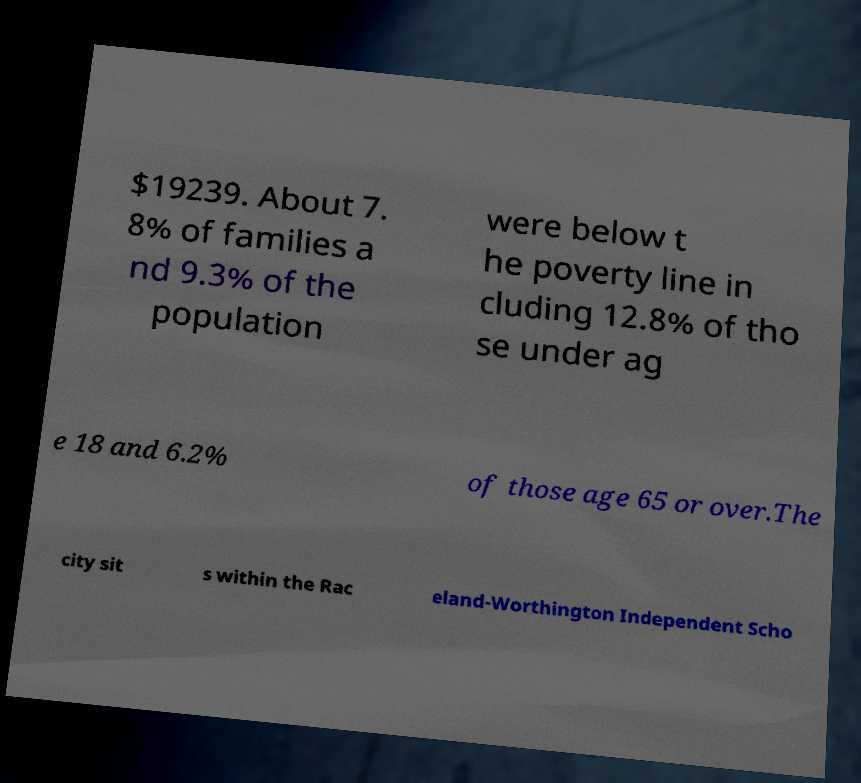There's text embedded in this image that I need extracted. Can you transcribe it verbatim? $19239. About 7. 8% of families a nd 9.3% of the population were below t he poverty line in cluding 12.8% of tho se under ag e 18 and 6.2% of those age 65 or over.The city sit s within the Rac eland-Worthington Independent Scho 